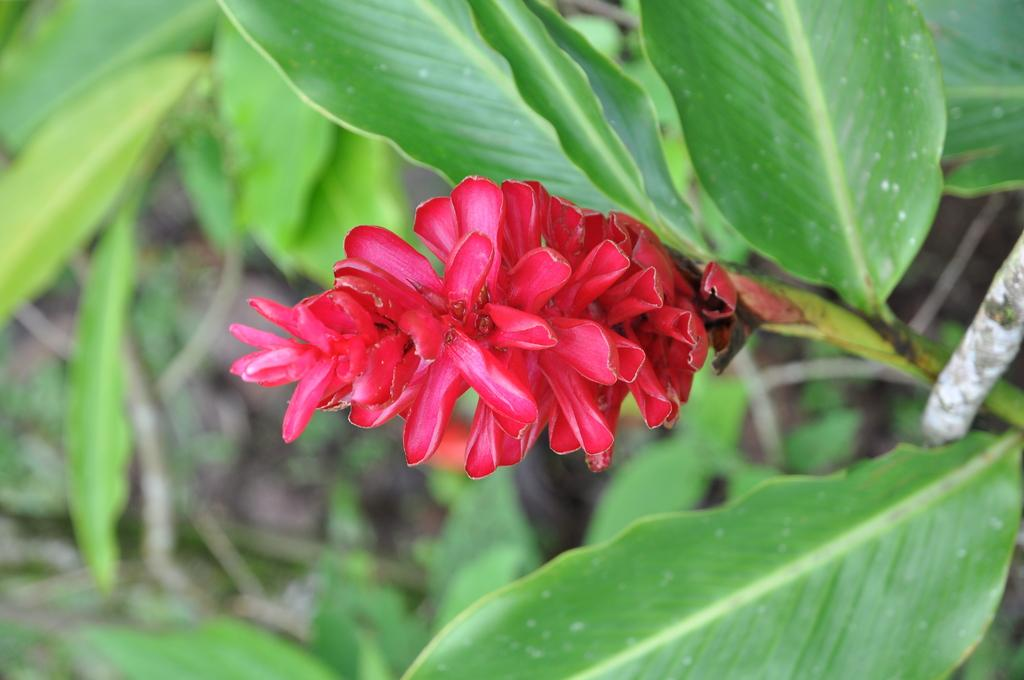What is present in the image? There is a plant in the image. What can be observed about the plant? The plant has a flower. What historical event is depicted in the image involving the plant and glue? There is no historical event, division, or glue present in the image; it only features a plant with a flower. 